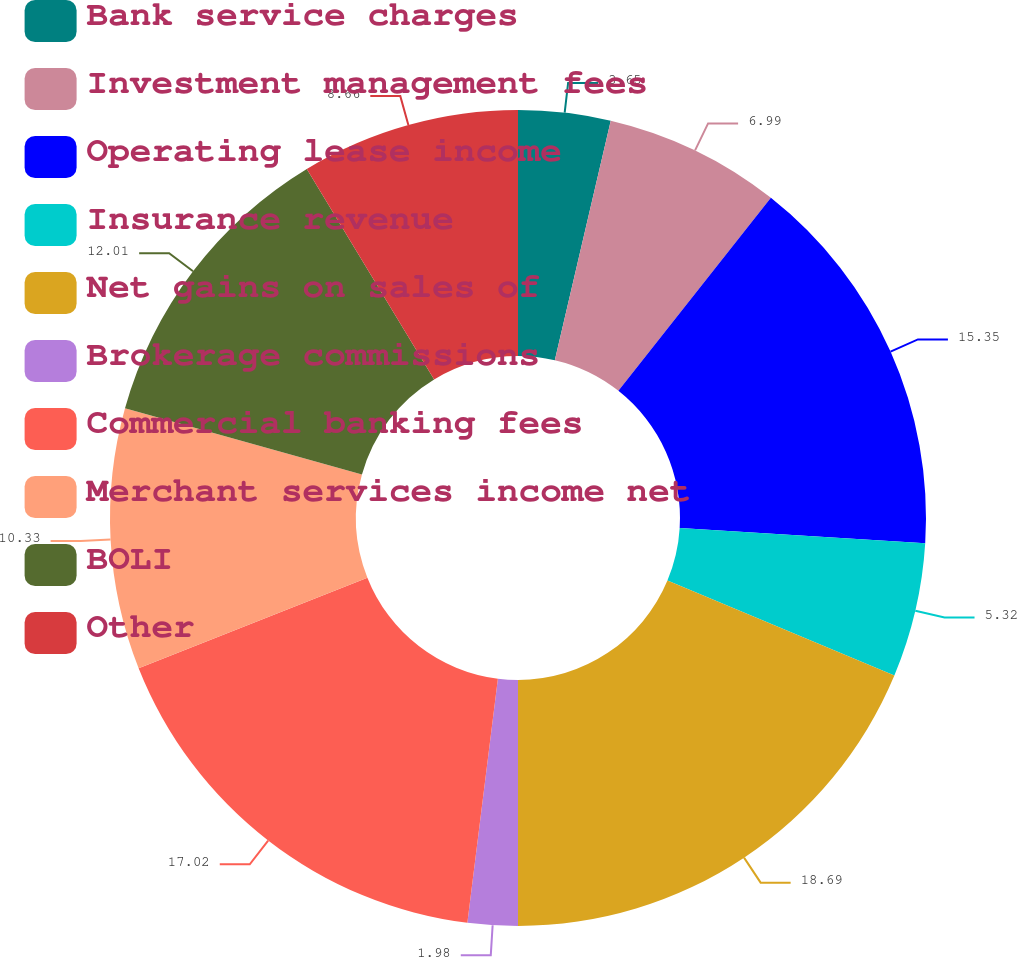Convert chart to OTSL. <chart><loc_0><loc_0><loc_500><loc_500><pie_chart><fcel>Bank service charges<fcel>Investment management fees<fcel>Operating lease income<fcel>Insurance revenue<fcel>Net gains on sales of<fcel>Brokerage commissions<fcel>Commercial banking fees<fcel>Merchant services income net<fcel>BOLI<fcel>Other<nl><fcel>3.65%<fcel>6.99%<fcel>15.35%<fcel>5.32%<fcel>18.69%<fcel>1.98%<fcel>17.02%<fcel>10.33%<fcel>12.01%<fcel>8.66%<nl></chart> 